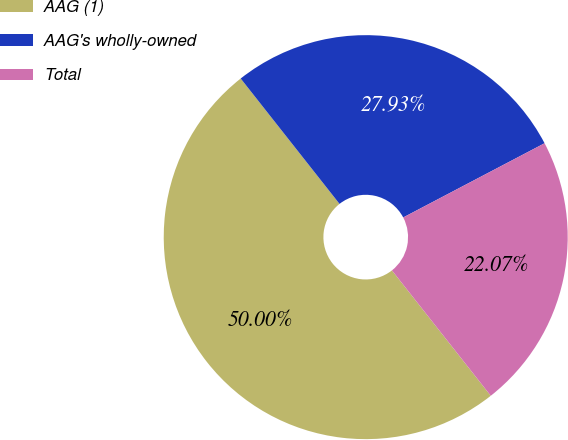<chart> <loc_0><loc_0><loc_500><loc_500><pie_chart><fcel>AAG (1)<fcel>AAG's wholly-owned<fcel>Total<nl><fcel>50.0%<fcel>27.93%<fcel>22.07%<nl></chart> 